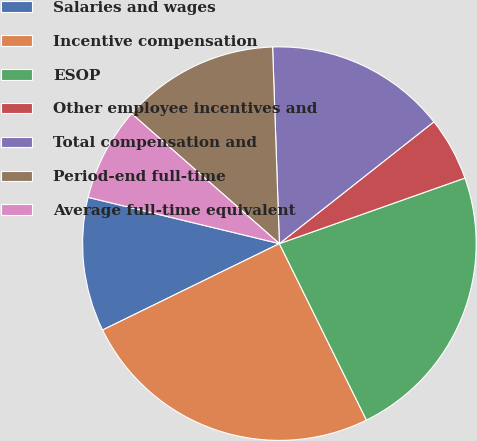Convert chart. <chart><loc_0><loc_0><loc_500><loc_500><pie_chart><fcel>Salaries and wages<fcel>Incentive compensation<fcel>ESOP<fcel>Other employee incentives and<fcel>Total compensation and<fcel>Period-end full-time<fcel>Average full-time equivalent<nl><fcel>11.01%<fcel>25.06%<fcel>23.11%<fcel>5.22%<fcel>14.92%<fcel>12.97%<fcel>7.7%<nl></chart> 